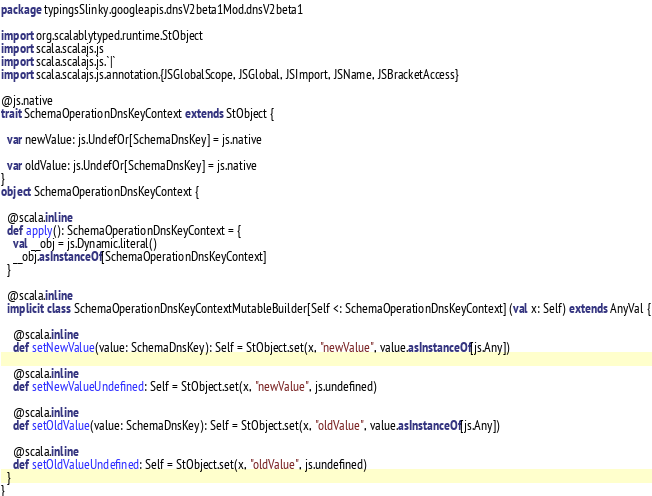<code> <loc_0><loc_0><loc_500><loc_500><_Scala_>package typingsSlinky.googleapis.dnsV2beta1Mod.dnsV2beta1

import org.scalablytyped.runtime.StObject
import scala.scalajs.js
import scala.scalajs.js.`|`
import scala.scalajs.js.annotation.{JSGlobalScope, JSGlobal, JSImport, JSName, JSBracketAccess}

@js.native
trait SchemaOperationDnsKeyContext extends StObject {
  
  var newValue: js.UndefOr[SchemaDnsKey] = js.native
  
  var oldValue: js.UndefOr[SchemaDnsKey] = js.native
}
object SchemaOperationDnsKeyContext {
  
  @scala.inline
  def apply(): SchemaOperationDnsKeyContext = {
    val __obj = js.Dynamic.literal()
    __obj.asInstanceOf[SchemaOperationDnsKeyContext]
  }
  
  @scala.inline
  implicit class SchemaOperationDnsKeyContextMutableBuilder[Self <: SchemaOperationDnsKeyContext] (val x: Self) extends AnyVal {
    
    @scala.inline
    def setNewValue(value: SchemaDnsKey): Self = StObject.set(x, "newValue", value.asInstanceOf[js.Any])
    
    @scala.inline
    def setNewValueUndefined: Self = StObject.set(x, "newValue", js.undefined)
    
    @scala.inline
    def setOldValue(value: SchemaDnsKey): Self = StObject.set(x, "oldValue", value.asInstanceOf[js.Any])
    
    @scala.inline
    def setOldValueUndefined: Self = StObject.set(x, "oldValue", js.undefined)
  }
}
</code> 